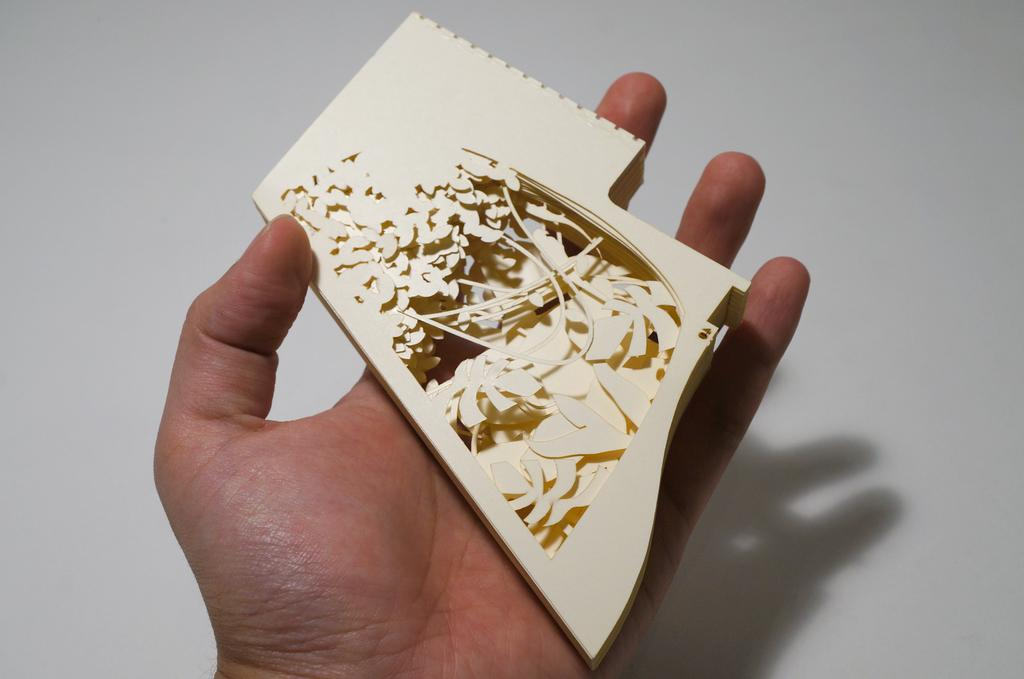What can be seen in the image that belongs to a person? There is a person's hand in the image. What is the person holding in their hand? There is an object in the person's hand. What can be seen behind the person's hand in the image? The background of the image appears to be a wall. What type of cream is being applied to the brake in the image? There is no cream or brake present in the image. 